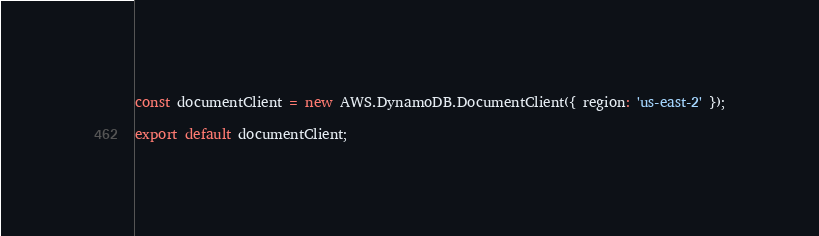<code> <loc_0><loc_0><loc_500><loc_500><_JavaScript_>const documentClient = new AWS.DynamoDB.DocumentClient({ region: 'us-east-2' });

export default documentClient;
</code> 